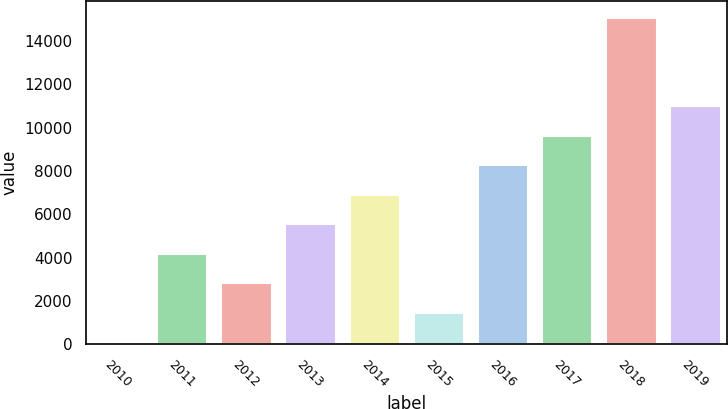Convert chart. <chart><loc_0><loc_0><loc_500><loc_500><bar_chart><fcel>2010<fcel>2011<fcel>2012<fcel>2013<fcel>2014<fcel>2015<fcel>2016<fcel>2017<fcel>2018<fcel>2019<nl><fcel>139<fcel>4227.1<fcel>2864.4<fcel>5589.8<fcel>6952.5<fcel>1501.7<fcel>8315.2<fcel>9677.9<fcel>15082.7<fcel>11040.6<nl></chart> 